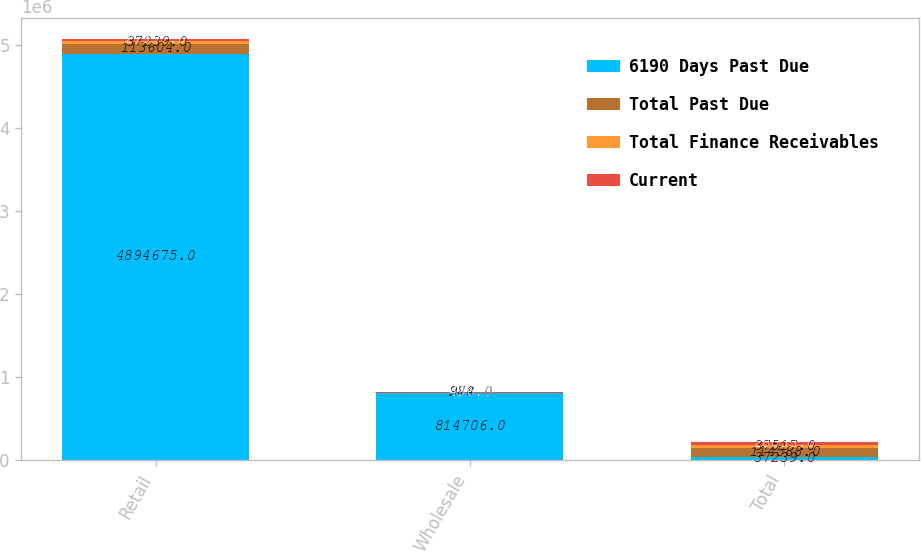Convert chart. <chart><loc_0><loc_0><loc_500><loc_500><stacked_bar_chart><ecel><fcel>Retail<fcel>Wholesale<fcel>Total<nl><fcel>6190 Days Past Due<fcel>4.89468e+06<fcel>814706<fcel>37239<nl><fcel>Total Past Due<fcel>113604<fcel>984<fcel>114588<nl><fcel>Total Finance Receivables<fcel>37239<fcel>278<fcel>37517<nl><fcel>Current<fcel>27597<fcel>436<fcel>28033<nl></chart> 